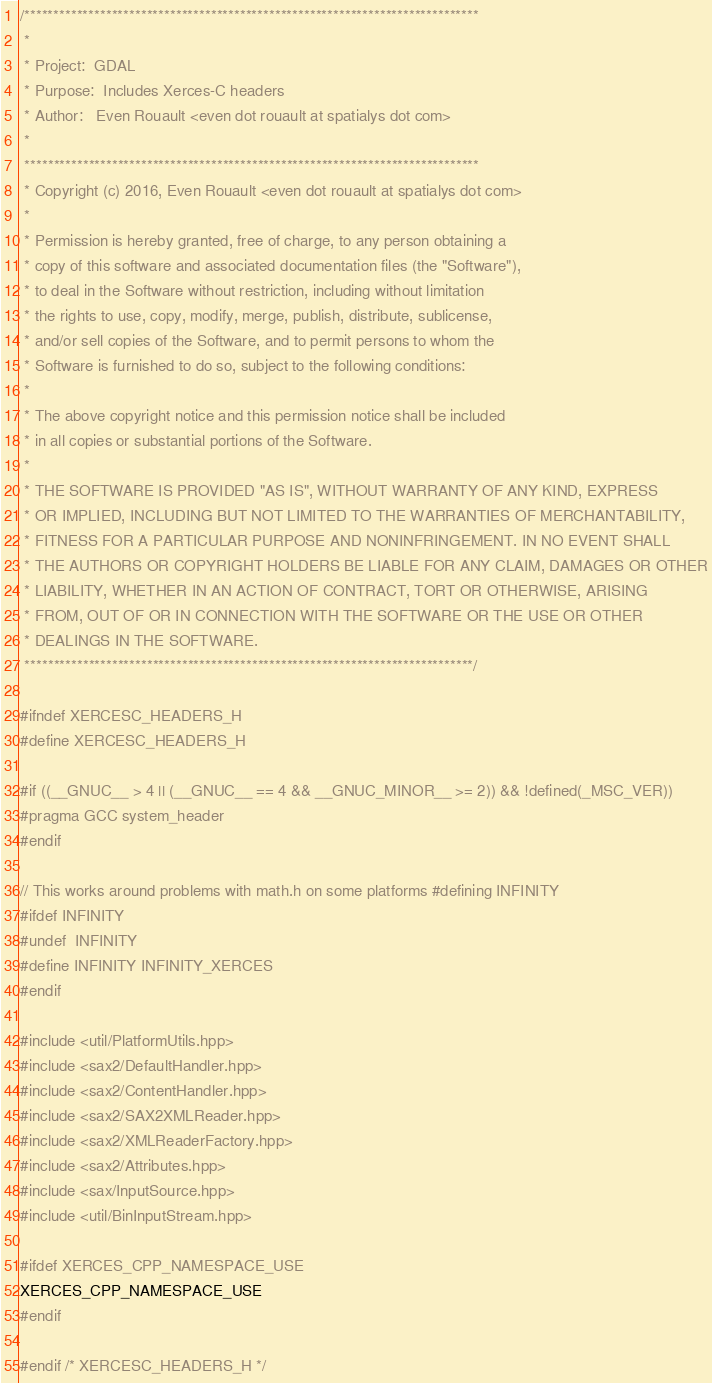<code> <loc_0><loc_0><loc_500><loc_500><_C_>/******************************************************************************
 *
 * Project:  GDAL
 * Purpose:  Includes Xerces-C headers
 * Author:   Even Rouault <even dot rouault at spatialys dot com>
 *
 ******************************************************************************
 * Copyright (c) 2016, Even Rouault <even dot rouault at spatialys dot com>
 *
 * Permission is hereby granted, free of charge, to any person obtaining a
 * copy of this software and associated documentation files (the "Software"),
 * to deal in the Software without restriction, including without limitation
 * the rights to use, copy, modify, merge, publish, distribute, sublicense,
 * and/or sell copies of the Software, and to permit persons to whom the
 * Software is furnished to do so, subject to the following conditions:
 *
 * The above copyright notice and this permission notice shall be included
 * in all copies or substantial portions of the Software.
 *
 * THE SOFTWARE IS PROVIDED "AS IS", WITHOUT WARRANTY OF ANY KIND, EXPRESS
 * OR IMPLIED, INCLUDING BUT NOT LIMITED TO THE WARRANTIES OF MERCHANTABILITY,
 * FITNESS FOR A PARTICULAR PURPOSE AND NONINFRINGEMENT. IN NO EVENT SHALL
 * THE AUTHORS OR COPYRIGHT HOLDERS BE LIABLE FOR ANY CLAIM, DAMAGES OR OTHER
 * LIABILITY, WHETHER IN AN ACTION OF CONTRACT, TORT OR OTHERWISE, ARISING
 * FROM, OUT OF OR IN CONNECTION WITH THE SOFTWARE OR THE USE OR OTHER
 * DEALINGS IN THE SOFTWARE.
 *****************************************************************************/

#ifndef XERCESC_HEADERS_H
#define XERCESC_HEADERS_H

#if ((__GNUC__ > 4 || (__GNUC__ == 4 && __GNUC_MINOR__ >= 2)) && !defined(_MSC_VER))
#pragma GCC system_header
#endif

// This works around problems with math.h on some platforms #defining INFINITY
#ifdef INFINITY
#undef  INFINITY
#define INFINITY INFINITY_XERCES
#endif

#include <util/PlatformUtils.hpp>
#include <sax2/DefaultHandler.hpp>
#include <sax2/ContentHandler.hpp>
#include <sax2/SAX2XMLReader.hpp>
#include <sax2/XMLReaderFactory.hpp>
#include <sax2/Attributes.hpp>
#include <sax/InputSource.hpp>
#include <util/BinInputStream.hpp>

#ifdef XERCES_CPP_NAMESPACE_USE
XERCES_CPP_NAMESPACE_USE
#endif

#endif /* XERCESC_HEADERS_H */
</code> 